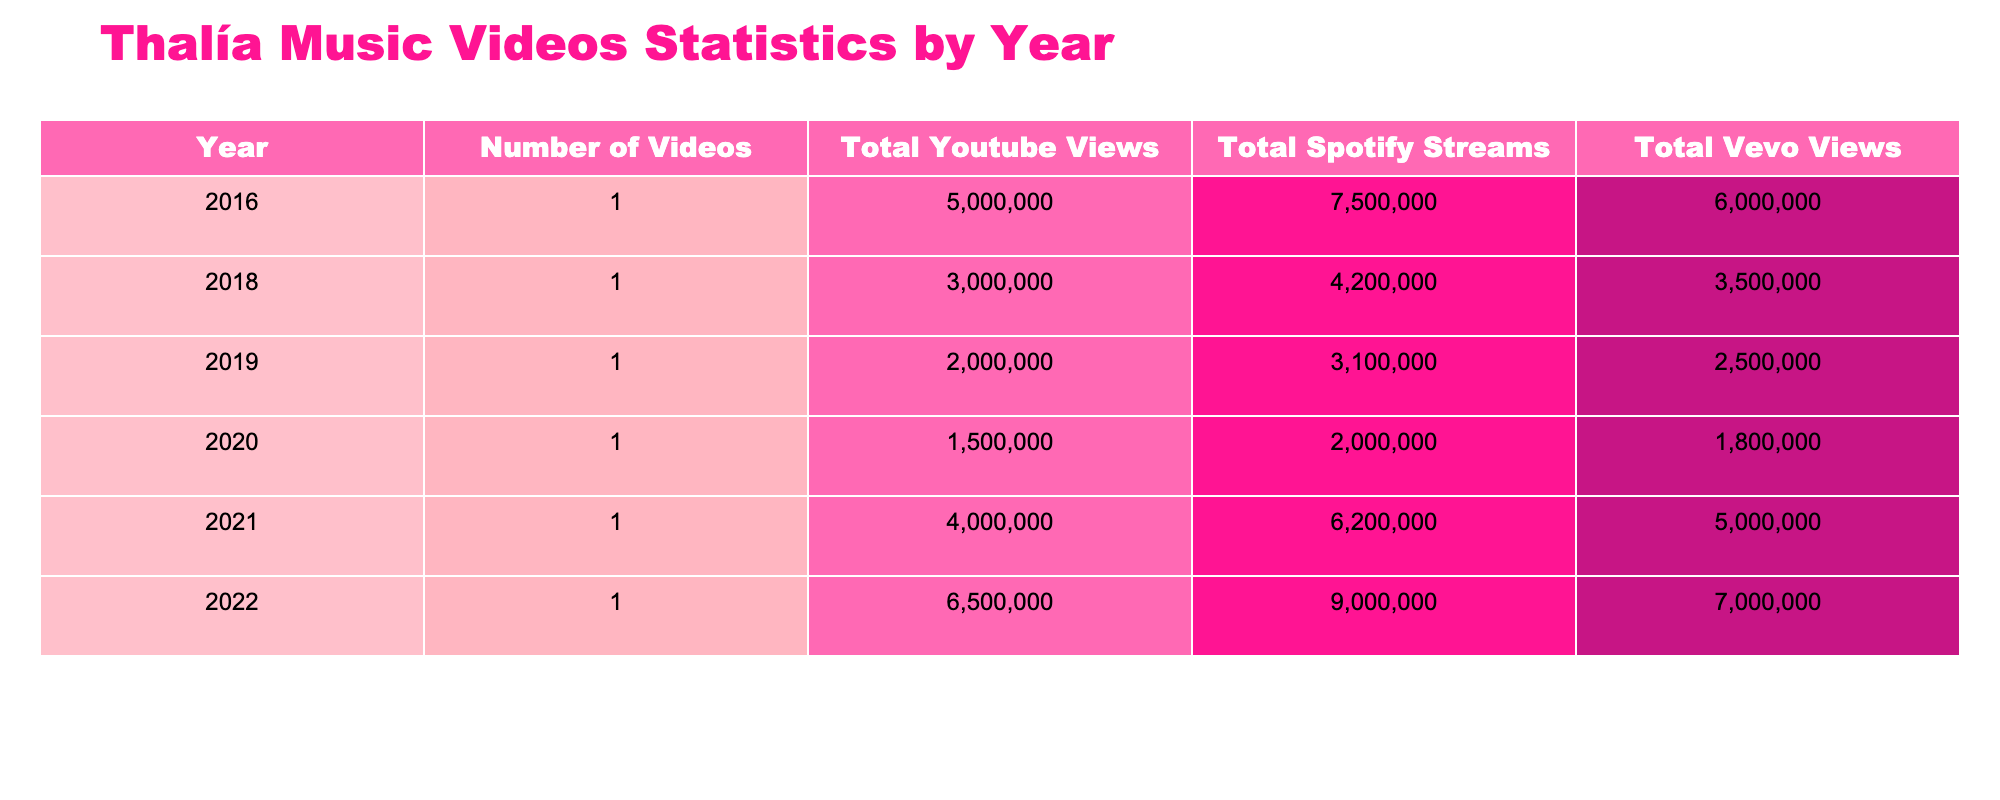What year had the highest total YouTube views for Thalía's music videos? To find the year with the highest total YouTube views, we look at the "Total Youtube Views" column in the table. The values are compared: 5,000,000 in 2016, 3,000,000 in 2018, 2,000,000 in 2019, 1,500,000 in 2020, 4,000,000 in 2021, and 6,500,000 in 2022. The highest value is 6,500,000, which corresponds to the year 2022.
Answer: 2022 Which platform had the lowest total streams across all years? We will compare the total streams for each platform. The total Spotify streams are 7,500,000 (2016) + 4,200,000 (2018) + 3,100,000 (2019) + 2,000,000 (2020) + 6,200,000 (2021) + 9,000,000 (2022), which totals to 32,000,000. The total YouTube views and total Vevo views can be similarly calculated, giving us totals of 17,500,000 and 19,000,000 respectively. Therefore, Spotify has the lowest total streams.
Answer: Spotify What is the difference between total Vevo views in 2022 and total YouTube views in 2016? We find the total Vevo views for 2022 (7,000,000) and total YouTube views for 2016 (5,000,000). The difference is calculated as 7,000,000 - 5,000,000, which equals 2,000,000.
Answer: 2,000,000 Did any year have the same total views across all three platforms? We compare the totals for each year. The totals are unique for YouTube, Spotify, and Vevo in every year, meaning there are no years where all three platforms show the same number of total views.
Answer: No What was the total number of videos released between 2019 and 2021? We check the years in the range from 2019 to 2021 which are 2019 (1 video), 2020 (1 video), and 2021 (1 video). By adding the counts of videos, we arrive at a total of 3 videos released in this period.
Answer: 3 